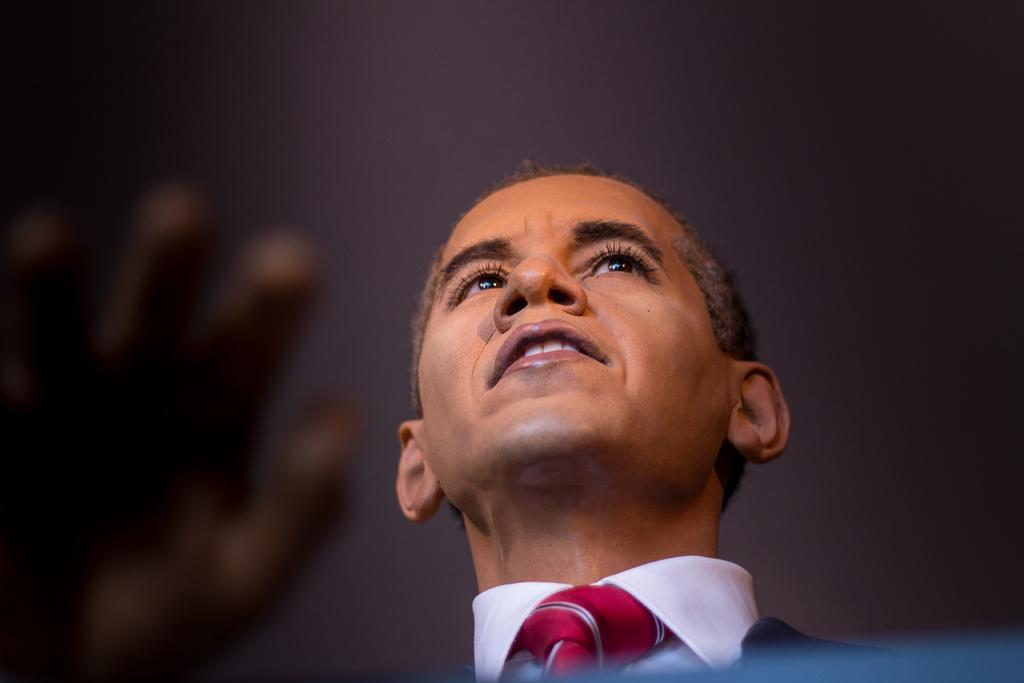What is the main subject in the image? There is a person in the image. Can you describe the surroundings of the person? The area around the person is blurry. What is the person's belief about the taste of the middle of the image? There is no information about the person's beliefs or the taste of the image, as the facts provided only mention the person and the blurry surroundings. 